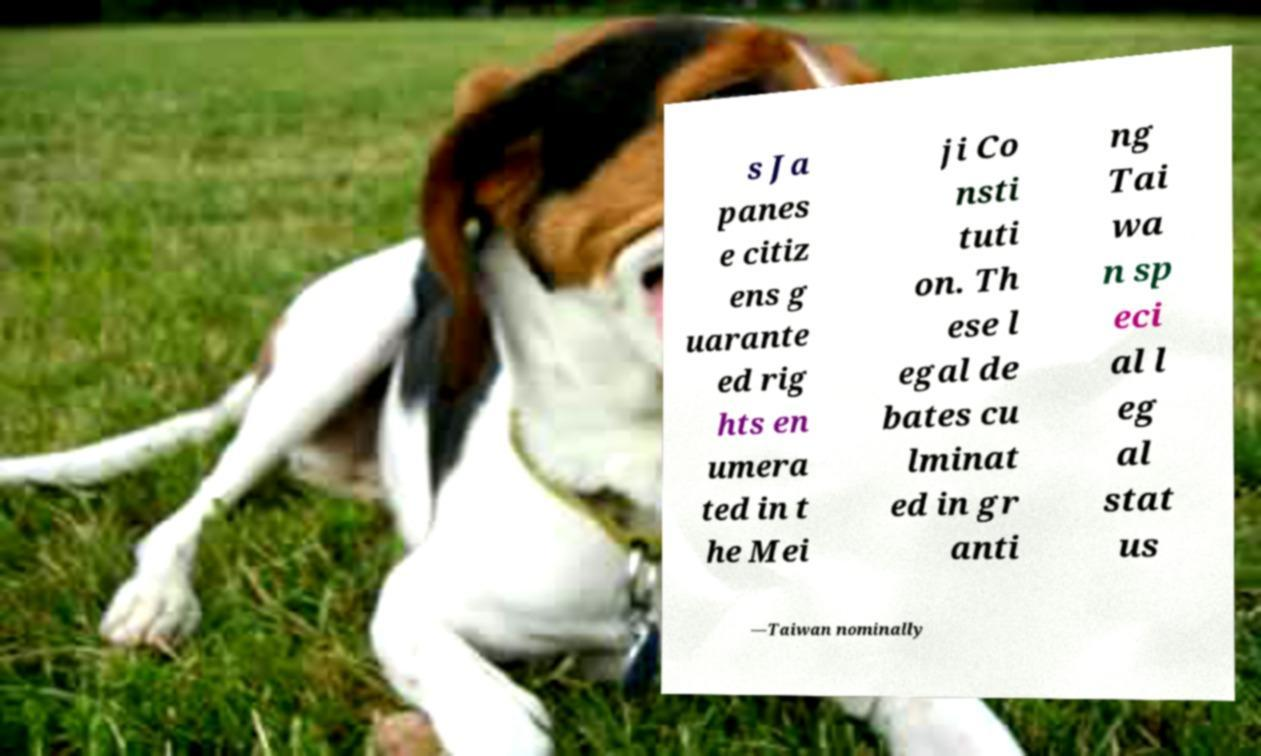For documentation purposes, I need the text within this image transcribed. Could you provide that? s Ja panes e citiz ens g uarante ed rig hts en umera ted in t he Mei ji Co nsti tuti on. Th ese l egal de bates cu lminat ed in gr anti ng Tai wa n sp eci al l eg al stat us —Taiwan nominally 